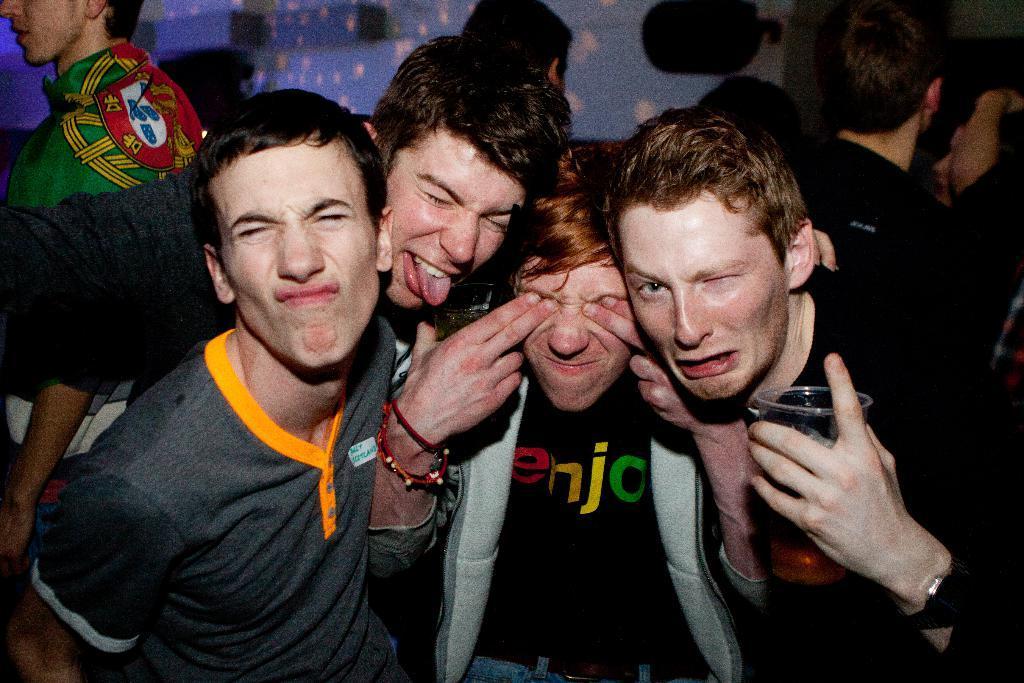In one or two sentences, can you explain what this image depicts? In this image I can see group of people among them this man is holding a glass in the hand. 